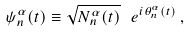<formula> <loc_0><loc_0><loc_500><loc_500>\psi _ { n } ^ { \alpha } ( t ) \equiv \sqrt { N _ { n } ^ { \alpha } ( t ) } \ e ^ { i \theta _ { n } ^ { \alpha } ( t ) } \, ,</formula> 